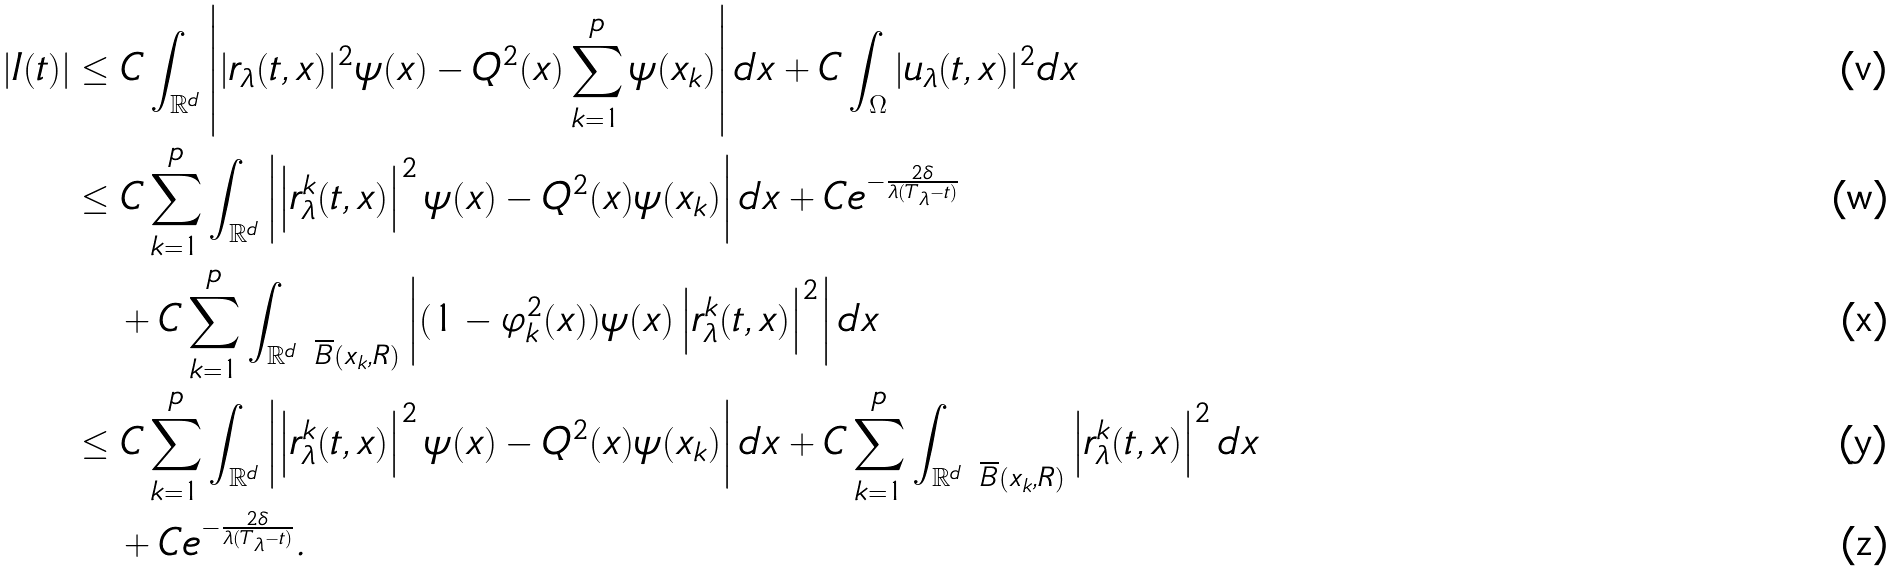<formula> <loc_0><loc_0><loc_500><loc_500>\left | I ( t ) \right | & \leq C \int _ { \mathbb { R } ^ { d } } \left | | r _ { \lambda } ( t , x ) | ^ { 2 } \psi ( x ) - Q ^ { 2 } ( x ) \sum _ { k = 1 } ^ { p } \psi ( x _ { k } ) \right | d x + C \int _ { \Omega } | u _ { \lambda } ( t , x ) | ^ { 2 } d x \\ & \leq C \sum _ { k = 1 } ^ { p } \int _ { \mathbb { R } ^ { d } } \left | \left | r _ { \lambda } ^ { k } ( t , x ) \right | ^ { 2 } \psi ( x ) - Q ^ { 2 } ( x ) \psi ( x _ { k } ) \right | d x + C e ^ { - \frac { 2 \delta } { \lambda ( T _ { \lambda } - t ) } } \\ & \quad + C \sum _ { k = 1 } ^ { p } \int _ { \mathbb { R } ^ { d } \ \overline { B } ( x _ { k } , R ) } \left | ( 1 - \varphi _ { k } ^ { 2 } ( x ) ) \psi ( x ) \left | r _ { \lambda } ^ { k } ( t , x ) \right | ^ { 2 } \right | d x \\ & \leq C \sum _ { k = 1 } ^ { p } \int _ { \mathbb { R } ^ { d } } \left | \left | r _ { \lambda } ^ { k } ( t , x ) \right | ^ { 2 } \psi ( x ) - Q ^ { 2 } ( x ) \psi ( x _ { k } ) \right | d x + C \sum _ { k = 1 } ^ { p } \int _ { \mathbb { R } ^ { d } \ \overline { B } ( x _ { k } , R ) } \left | r _ { \lambda } ^ { k } ( t , x ) \right | ^ { 2 } d x \\ & \quad + C e ^ { - \frac { 2 \delta } { \lambda ( T _ { \lambda } - t ) } } .</formula> 